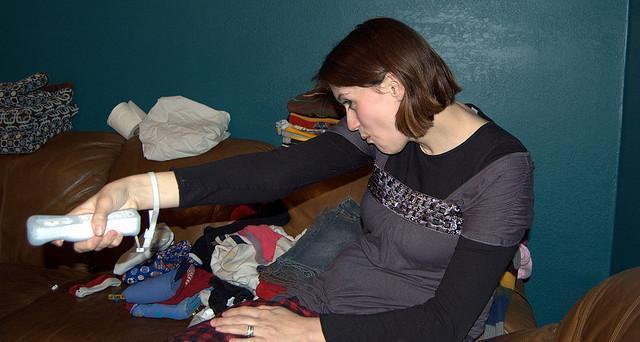How many hands is she using to hold controllers?
Give a very brief answer. 1. How many couches are in the photo?
Give a very brief answer. 3. How many people can you see?
Give a very brief answer. 1. How many giraffes have visible legs?
Give a very brief answer. 0. 